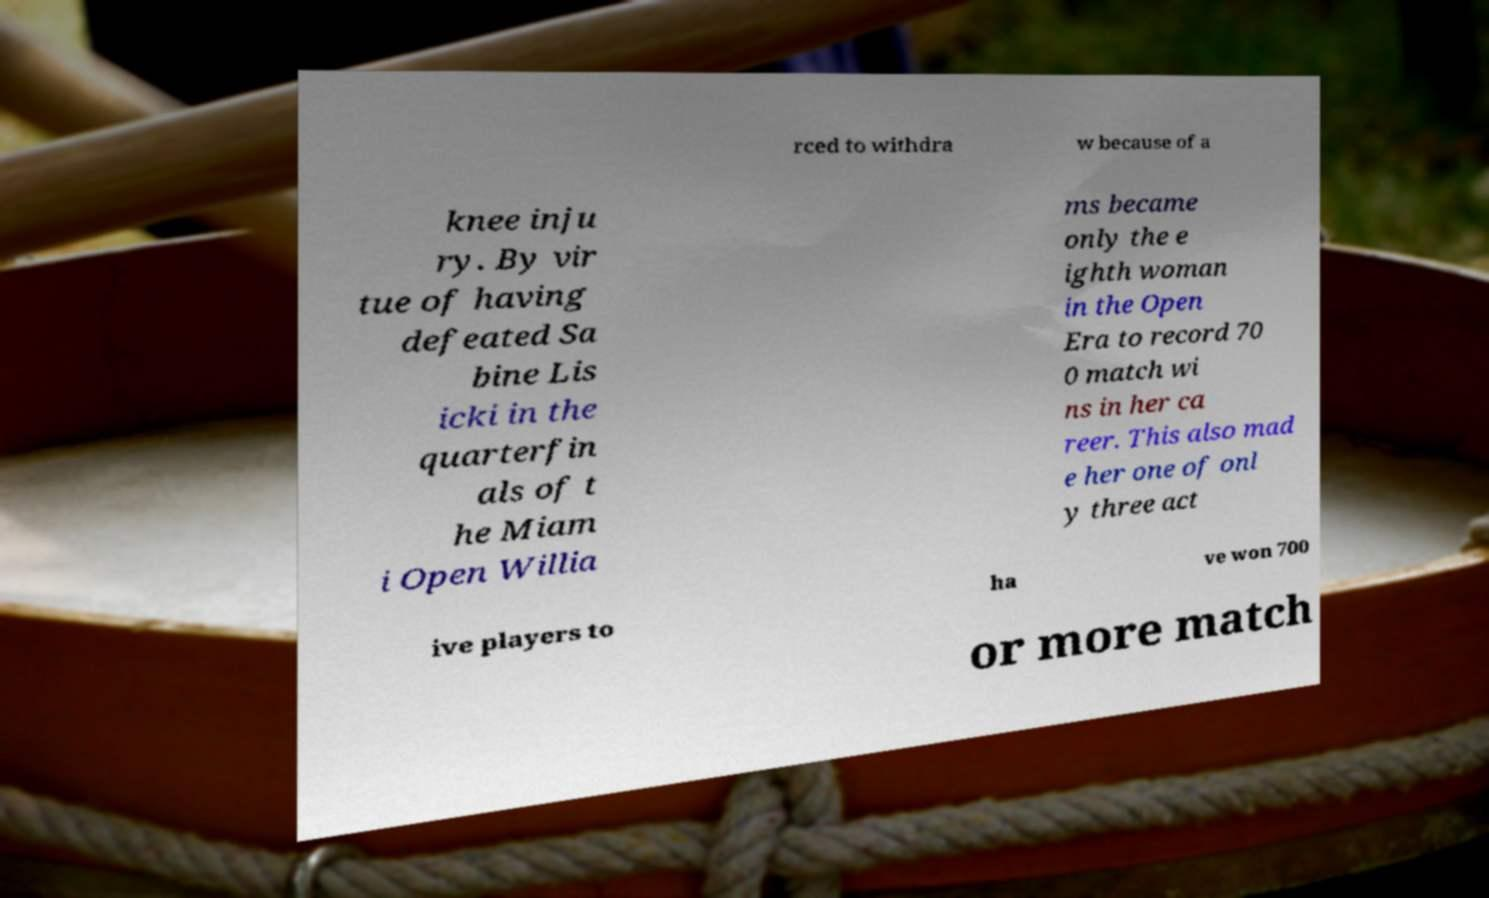Can you accurately transcribe the text from the provided image for me? rced to withdra w because of a knee inju ry. By vir tue of having defeated Sa bine Lis icki in the quarterfin als of t he Miam i Open Willia ms became only the e ighth woman in the Open Era to record 70 0 match wi ns in her ca reer. This also mad e her one of onl y three act ive players to ha ve won 700 or more match 